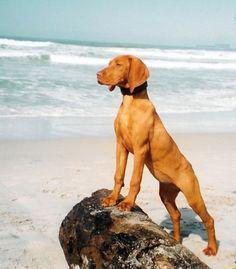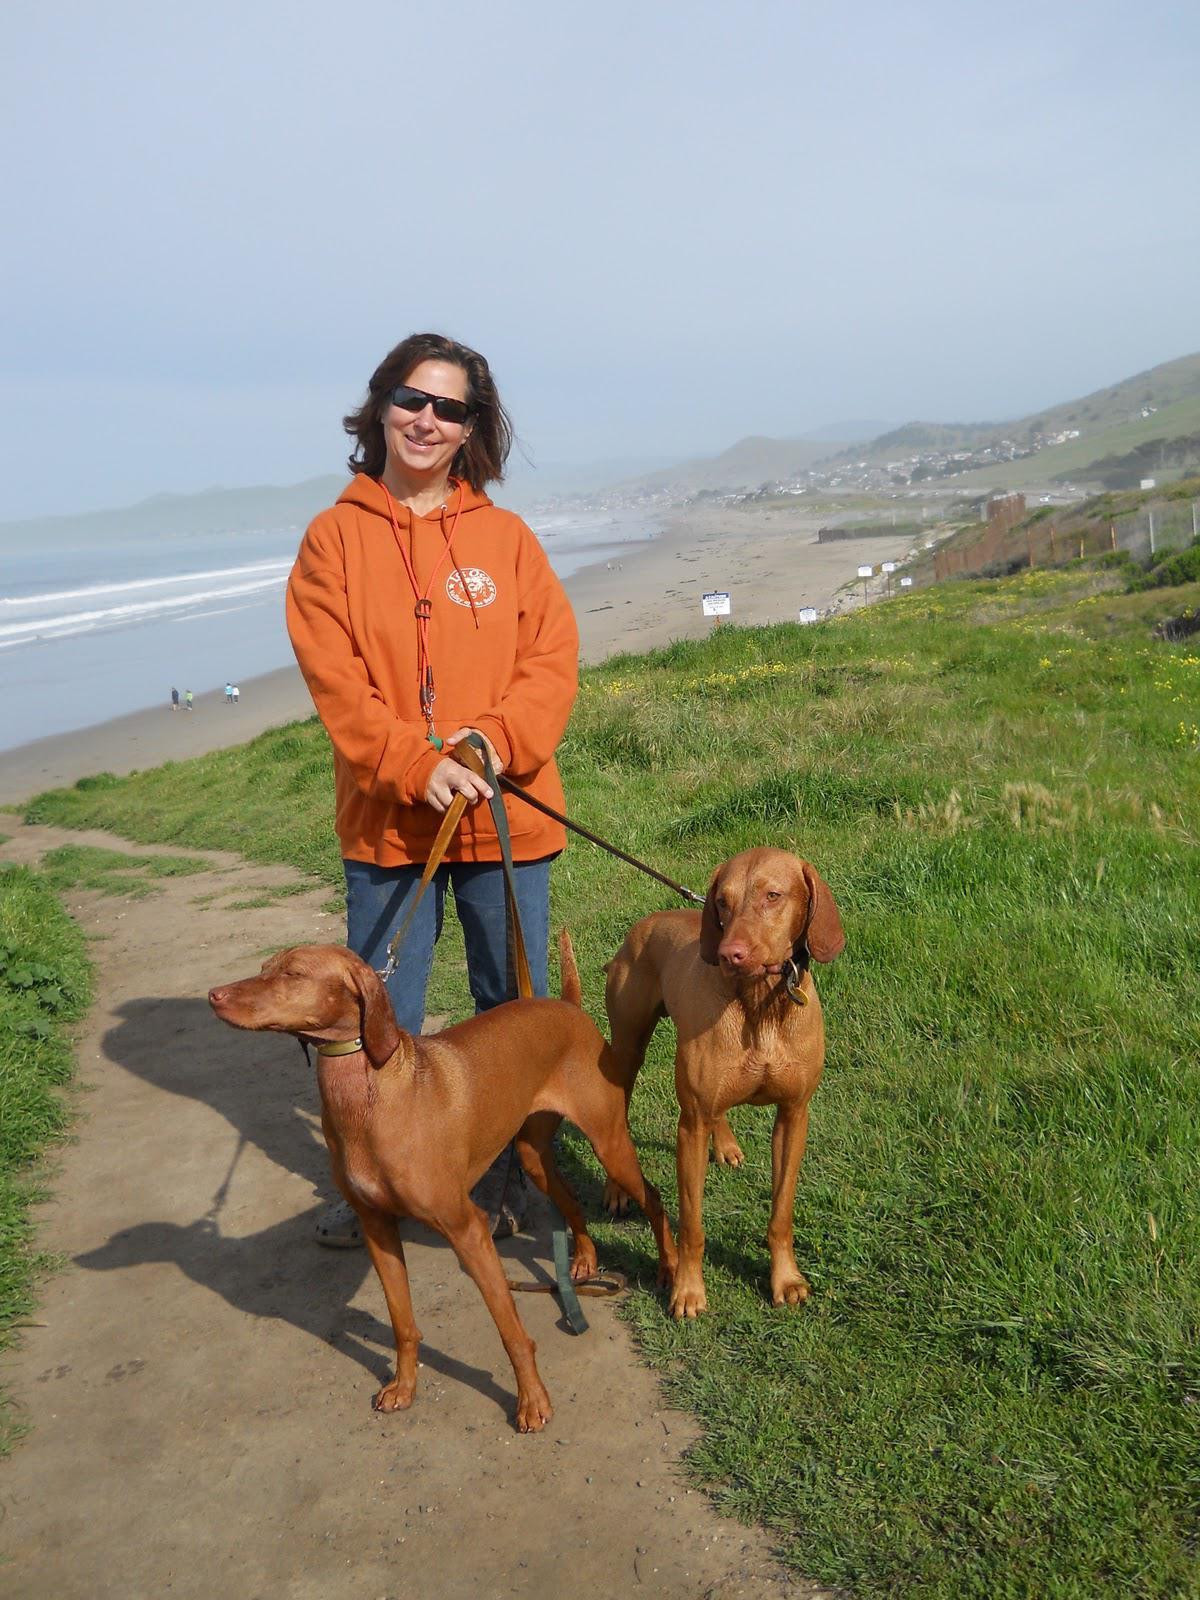The first image is the image on the left, the second image is the image on the right. Evaluate the accuracy of this statement regarding the images: "There's at least one dog on a leash in one picture and the other picture of a dog is taken at the beach.". Is it true? Answer yes or no. Yes. The first image is the image on the left, the second image is the image on the right. Given the left and right images, does the statement "A female is standing behind a dog with its head and body turned leftward in the right image." hold true? Answer yes or no. Yes. 